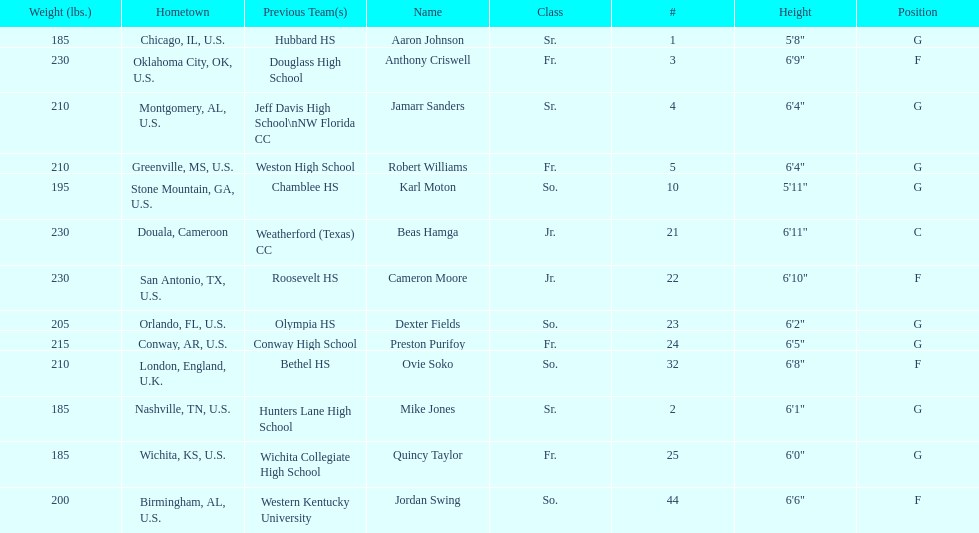Who is first on the roster? Aaron Johnson. 